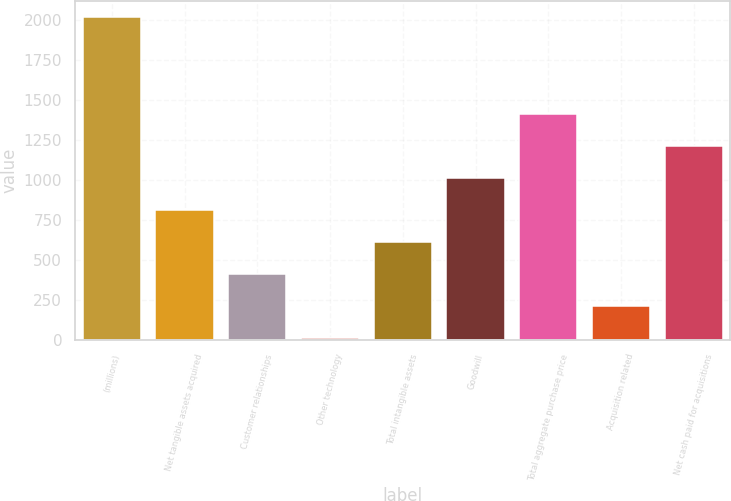Convert chart. <chart><loc_0><loc_0><loc_500><loc_500><bar_chart><fcel>(millions)<fcel>Net tangible assets acquired<fcel>Customer relationships<fcel>Other technology<fcel>Total intangible assets<fcel>Goodwill<fcel>Total aggregate purchase price<fcel>Acquisition related<fcel>Net cash paid for acquisitions<nl><fcel>2015<fcel>811.22<fcel>409.96<fcel>8.7<fcel>610.59<fcel>1011.85<fcel>1413.11<fcel>209.33<fcel>1212.48<nl></chart> 